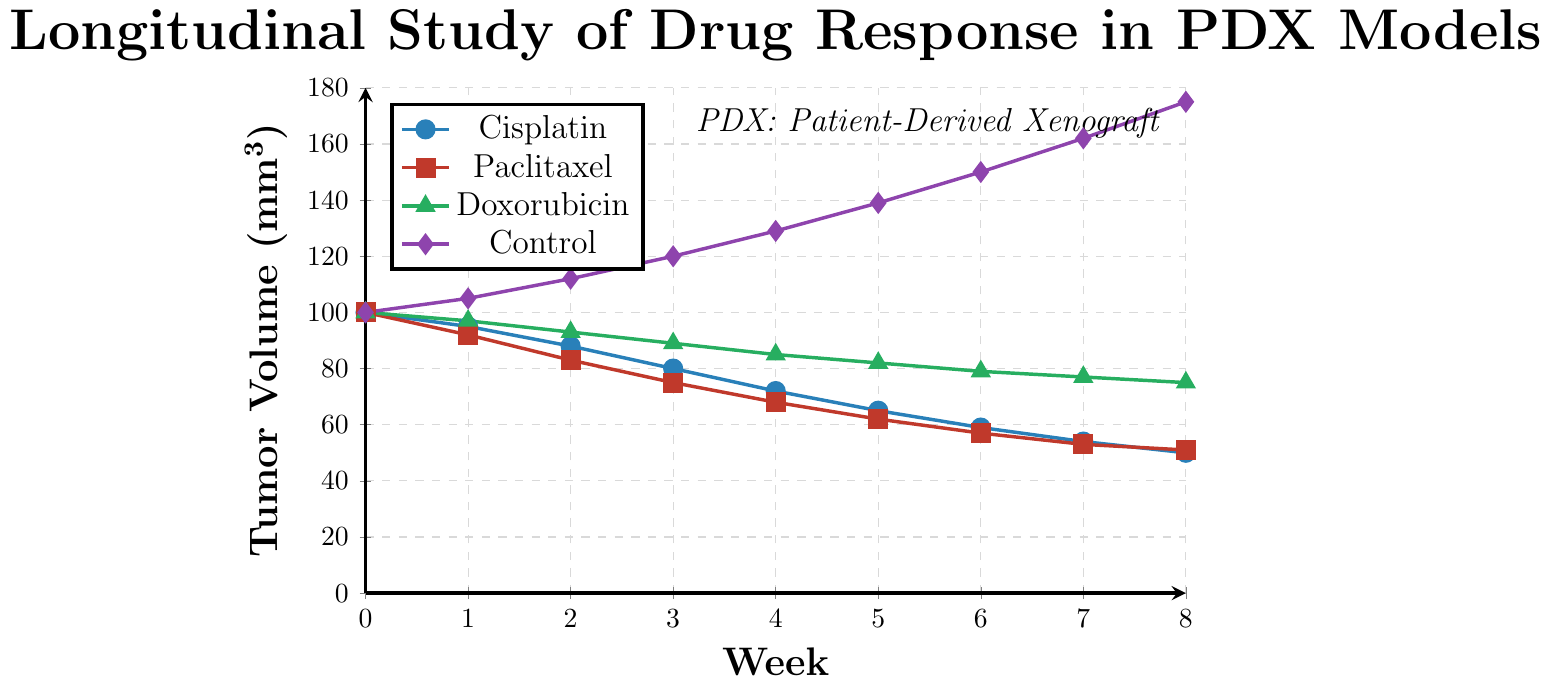What is the tumor volume for Paclitaxel at Week 4? The data label for Paclitaxel is "red" with square markers. At Week 4, the tumor volume is at the intersection of the vertical line from Week 4 and the horizontal line from the red square marker, which shows a value of 68.
Answer: 68 Which treatment shows the greatest reduction in tumor volume over the 8-week period? To find the treatment with the greatest reduction, we need to compare the decrease in tumor volumes from Week 0 to Week 8 for each treatment. The volumes changed from 100 to 50 for Cisplatin, 100 to 51 for Paclitaxel, 100 to 75 for Doxorubicin, and increased from 100 to 175 for Control. Thus, the largest reduction is seen in Cisplatin, dropping by 50 units.
Answer: Cisplatin What is the average tumor volume for the Doxorubicin treatment over the 8-week period? To find the average, sum the tumor volumes for Doxorubicin at each week and then divide by the number of weeks plus the initial point: (100 + 97 + 93 + 89 + 85 + 82 + 79 + 77 + 75) / 9. The total is 777, and the average is 777/9 ≈ 86.33.
Answer: ~86.33 By how much does the tumor volume for the control group increase from Week 3 to Week 7? For the control group (denoted as purple with diamond markers), the tumor volume at Week 3 is 120 and at Week 7 is 162. The increase in volume is 162 - 120 = 42.
Answer: 42 What trend do you observe in the tumor volume for Cisplatin from Week 3 to Week 7? For Cisplatin (blue circle markers), the tumor volume continuously decreases. At Week 3, the volume is 80, and it reduces incrementally to 54 by Week 7. This shows a consistent downward trend in tumor volume.
Answer: Decreasing Compare the efficacy of Cisplatin and Paclitaxel at Week 8. Which drug performs better? At Week 8, Cisplatin (blue circle markers) has a tumor volume of 50, while Paclitaxel (red square markers) has a tumor volume of 51. Cisplatin has a slightly lower volume, indicating better performance.
Answer: Cisplatin What is the difference in tumor volume between Cisplatin and Control at Week 5? At Week 5, Cisplatin has a tumor volume of 65 (blue circle markers), and Control has a volume of 139 (purple diamond markers). The difference is 139 - 65 = 74.
Answer: 74 How many weeks does it take for the tumor volume to fall below 90 mm³ for Paclitaxel? Looking at the red square markers for Paclitaxel, the volume falls below 90 mm³ between Week 2 (83) and Week 3 (75). It takes between 2 and 3 weeks.
Answer: Between 2 and 3 weeks What is the total change in tumor volume for Doxorubicin from Week 0 to Week 8? Initially, the volume for Doxorubicin (green triangle markers) is 100, and at Week 8, it is 75. The total change is 100 - 75 = 25.
Answer: 25 Which drug shows the slowest rate of tumor volume decrease, based on the slopes of the lines in the graph? Comparing the slopes of the lines for the drugs, Doxorubicin (green triangle markers) shows the slowest rate of decrease, with a relatively flatter decline in tumor volume over time compared to Cisplatin and Paclitaxel.
Answer: Doxorubicin 